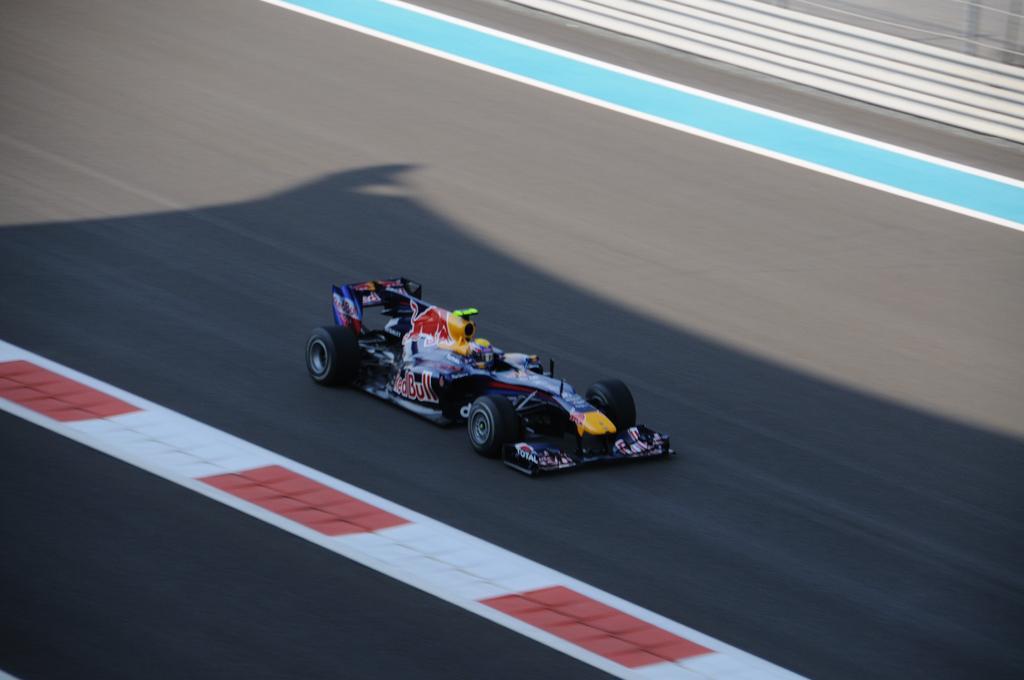In one or two sentences, can you explain what this image depicts? This image consists of a racing car. There is a road in the middle. There is a person in that car. 